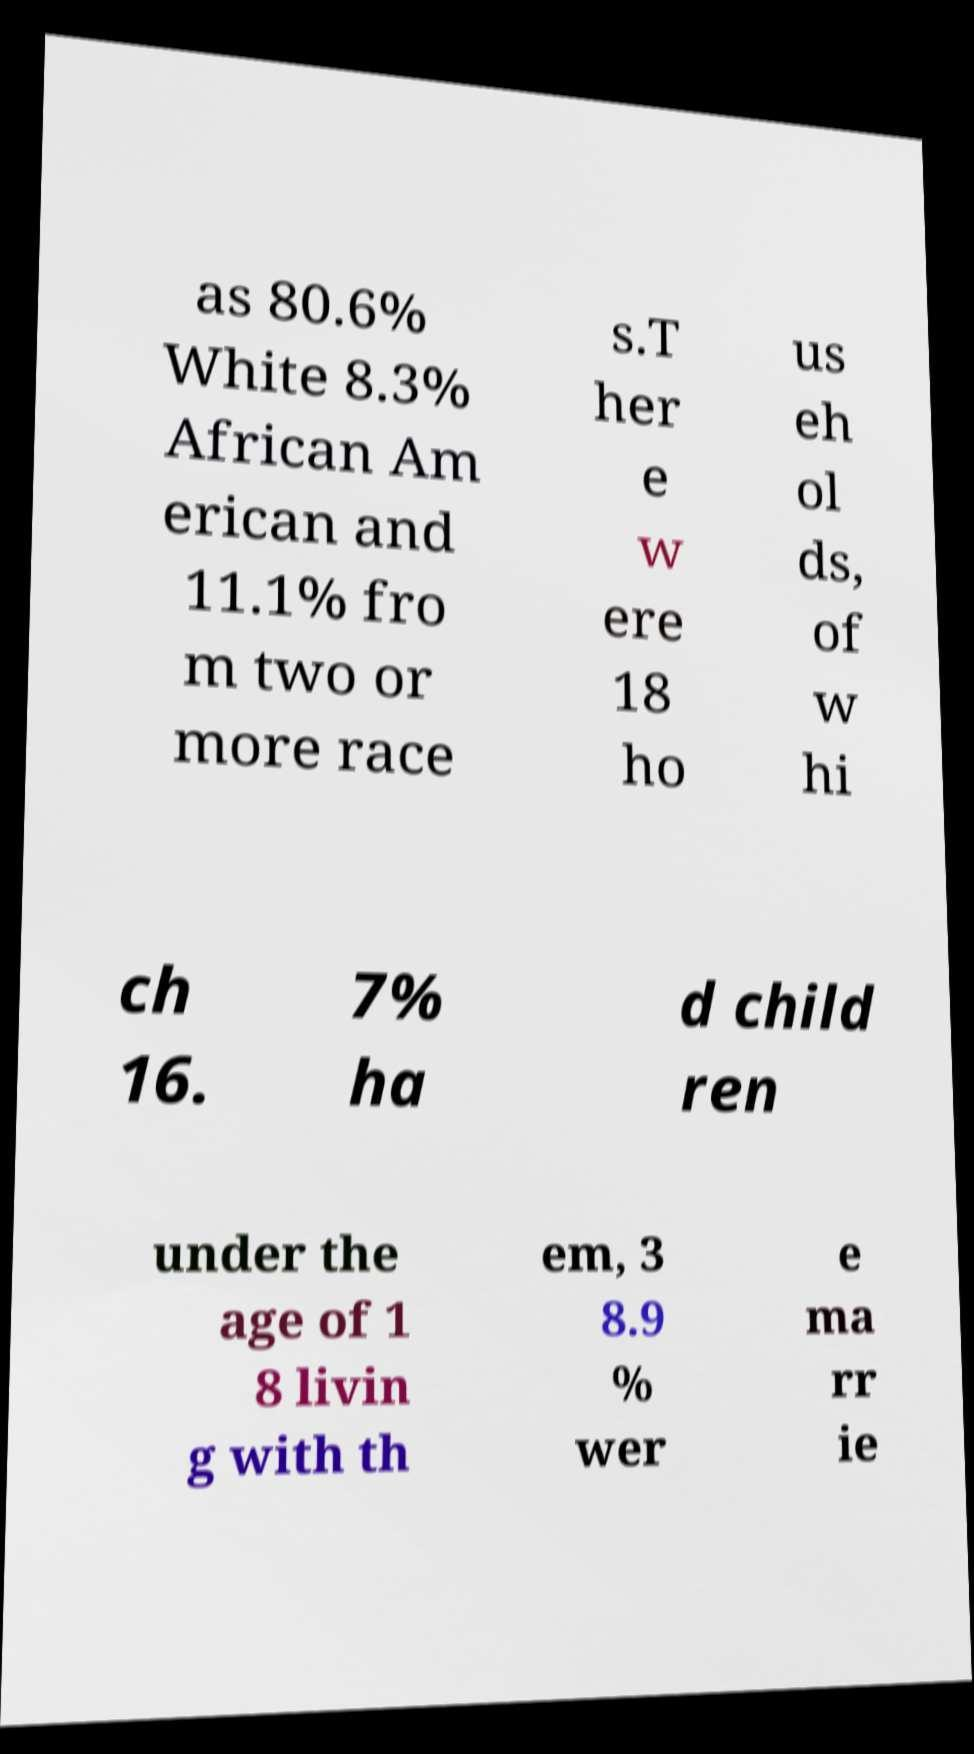Please read and relay the text visible in this image. What does it say? as 80.6% White 8.3% African Am erican and 11.1% fro m two or more race s.T her e w ere 18 ho us eh ol ds, of w hi ch 16. 7% ha d child ren under the age of 1 8 livin g with th em, 3 8.9 % wer e ma rr ie 